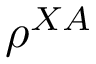<formula> <loc_0><loc_0><loc_500><loc_500>\rho ^ { X A }</formula> 